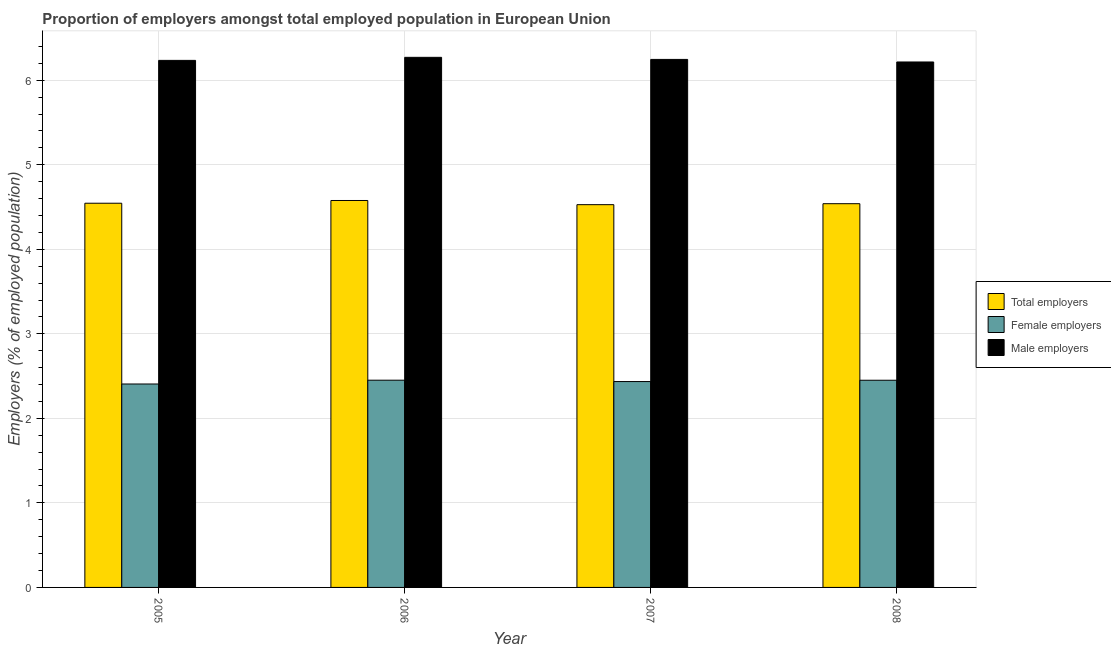How many different coloured bars are there?
Offer a terse response. 3. Are the number of bars on each tick of the X-axis equal?
Provide a succinct answer. Yes. How many bars are there on the 2nd tick from the right?
Your answer should be very brief. 3. What is the label of the 4th group of bars from the left?
Offer a terse response. 2008. In how many cases, is the number of bars for a given year not equal to the number of legend labels?
Offer a terse response. 0. What is the percentage of female employers in 2007?
Your answer should be compact. 2.44. Across all years, what is the maximum percentage of total employers?
Give a very brief answer. 4.58. Across all years, what is the minimum percentage of total employers?
Give a very brief answer. 4.53. In which year was the percentage of female employers maximum?
Offer a terse response. 2006. What is the total percentage of female employers in the graph?
Ensure brevity in your answer.  9.74. What is the difference between the percentage of female employers in 2006 and that in 2008?
Provide a succinct answer. 0. What is the difference between the percentage of total employers in 2006 and the percentage of male employers in 2005?
Your response must be concise. 0.03. What is the average percentage of male employers per year?
Offer a terse response. 6.24. What is the ratio of the percentage of male employers in 2006 to that in 2007?
Your response must be concise. 1. Is the percentage of male employers in 2005 less than that in 2007?
Provide a succinct answer. Yes. Is the difference between the percentage of total employers in 2005 and 2008 greater than the difference between the percentage of female employers in 2005 and 2008?
Give a very brief answer. No. What is the difference between the highest and the second highest percentage of male employers?
Your answer should be very brief. 0.02. What is the difference between the highest and the lowest percentage of total employers?
Provide a succinct answer. 0.05. In how many years, is the percentage of total employers greater than the average percentage of total employers taken over all years?
Give a very brief answer. 1. What does the 3rd bar from the left in 2007 represents?
Your answer should be very brief. Male employers. What does the 1st bar from the right in 2006 represents?
Offer a very short reply. Male employers. Is it the case that in every year, the sum of the percentage of total employers and percentage of female employers is greater than the percentage of male employers?
Provide a short and direct response. Yes. How many bars are there?
Ensure brevity in your answer.  12. What is the difference between two consecutive major ticks on the Y-axis?
Give a very brief answer. 1. Are the values on the major ticks of Y-axis written in scientific E-notation?
Your answer should be compact. No. Where does the legend appear in the graph?
Your response must be concise. Center right. How are the legend labels stacked?
Give a very brief answer. Vertical. What is the title of the graph?
Your answer should be compact. Proportion of employers amongst total employed population in European Union. What is the label or title of the Y-axis?
Your answer should be very brief. Employers (% of employed population). What is the Employers (% of employed population) of Total employers in 2005?
Give a very brief answer. 4.54. What is the Employers (% of employed population) of Female employers in 2005?
Ensure brevity in your answer.  2.41. What is the Employers (% of employed population) in Male employers in 2005?
Offer a terse response. 6.23. What is the Employers (% of employed population) of Total employers in 2006?
Give a very brief answer. 4.58. What is the Employers (% of employed population) of Female employers in 2006?
Your response must be concise. 2.45. What is the Employers (% of employed population) in Male employers in 2006?
Ensure brevity in your answer.  6.27. What is the Employers (% of employed population) in Total employers in 2007?
Your answer should be compact. 4.53. What is the Employers (% of employed population) in Female employers in 2007?
Your answer should be very brief. 2.44. What is the Employers (% of employed population) of Male employers in 2007?
Your response must be concise. 6.25. What is the Employers (% of employed population) of Total employers in 2008?
Your answer should be compact. 4.54. What is the Employers (% of employed population) of Female employers in 2008?
Offer a very short reply. 2.45. What is the Employers (% of employed population) in Male employers in 2008?
Your answer should be very brief. 6.22. Across all years, what is the maximum Employers (% of employed population) in Total employers?
Your answer should be very brief. 4.58. Across all years, what is the maximum Employers (% of employed population) of Female employers?
Keep it short and to the point. 2.45. Across all years, what is the maximum Employers (% of employed population) of Male employers?
Offer a terse response. 6.27. Across all years, what is the minimum Employers (% of employed population) of Total employers?
Offer a terse response. 4.53. Across all years, what is the minimum Employers (% of employed population) of Female employers?
Offer a terse response. 2.41. Across all years, what is the minimum Employers (% of employed population) of Male employers?
Make the answer very short. 6.22. What is the total Employers (% of employed population) in Total employers in the graph?
Provide a short and direct response. 18.19. What is the total Employers (% of employed population) of Female employers in the graph?
Your answer should be very brief. 9.74. What is the total Employers (% of employed population) in Male employers in the graph?
Your response must be concise. 24.97. What is the difference between the Employers (% of employed population) of Total employers in 2005 and that in 2006?
Your response must be concise. -0.03. What is the difference between the Employers (% of employed population) of Female employers in 2005 and that in 2006?
Offer a very short reply. -0.04. What is the difference between the Employers (% of employed population) in Male employers in 2005 and that in 2006?
Your response must be concise. -0.04. What is the difference between the Employers (% of employed population) of Total employers in 2005 and that in 2007?
Your answer should be compact. 0.02. What is the difference between the Employers (% of employed population) in Female employers in 2005 and that in 2007?
Your response must be concise. -0.03. What is the difference between the Employers (% of employed population) of Male employers in 2005 and that in 2007?
Your response must be concise. -0.01. What is the difference between the Employers (% of employed population) in Total employers in 2005 and that in 2008?
Your response must be concise. 0.01. What is the difference between the Employers (% of employed population) of Female employers in 2005 and that in 2008?
Offer a terse response. -0.04. What is the difference between the Employers (% of employed population) in Male employers in 2005 and that in 2008?
Provide a short and direct response. 0.02. What is the difference between the Employers (% of employed population) in Total employers in 2006 and that in 2007?
Ensure brevity in your answer.  0.05. What is the difference between the Employers (% of employed population) in Female employers in 2006 and that in 2007?
Provide a succinct answer. 0.02. What is the difference between the Employers (% of employed population) of Male employers in 2006 and that in 2007?
Your response must be concise. 0.02. What is the difference between the Employers (% of employed population) in Total employers in 2006 and that in 2008?
Offer a terse response. 0.04. What is the difference between the Employers (% of employed population) of Female employers in 2006 and that in 2008?
Offer a terse response. 0. What is the difference between the Employers (% of employed population) in Male employers in 2006 and that in 2008?
Your answer should be very brief. 0.06. What is the difference between the Employers (% of employed population) of Total employers in 2007 and that in 2008?
Offer a very short reply. -0.01. What is the difference between the Employers (% of employed population) in Female employers in 2007 and that in 2008?
Offer a very short reply. -0.02. What is the difference between the Employers (% of employed population) in Male employers in 2007 and that in 2008?
Provide a short and direct response. 0.03. What is the difference between the Employers (% of employed population) of Total employers in 2005 and the Employers (% of employed population) of Female employers in 2006?
Your response must be concise. 2.09. What is the difference between the Employers (% of employed population) of Total employers in 2005 and the Employers (% of employed population) of Male employers in 2006?
Give a very brief answer. -1.73. What is the difference between the Employers (% of employed population) of Female employers in 2005 and the Employers (% of employed population) of Male employers in 2006?
Offer a terse response. -3.86. What is the difference between the Employers (% of employed population) in Total employers in 2005 and the Employers (% of employed population) in Female employers in 2007?
Give a very brief answer. 2.11. What is the difference between the Employers (% of employed population) of Total employers in 2005 and the Employers (% of employed population) of Male employers in 2007?
Ensure brevity in your answer.  -1.7. What is the difference between the Employers (% of employed population) in Female employers in 2005 and the Employers (% of employed population) in Male employers in 2007?
Provide a short and direct response. -3.84. What is the difference between the Employers (% of employed population) of Total employers in 2005 and the Employers (% of employed population) of Female employers in 2008?
Your answer should be compact. 2.09. What is the difference between the Employers (% of employed population) of Total employers in 2005 and the Employers (% of employed population) of Male employers in 2008?
Your answer should be compact. -1.67. What is the difference between the Employers (% of employed population) in Female employers in 2005 and the Employers (% of employed population) in Male employers in 2008?
Make the answer very short. -3.81. What is the difference between the Employers (% of employed population) in Total employers in 2006 and the Employers (% of employed population) in Female employers in 2007?
Your answer should be compact. 2.14. What is the difference between the Employers (% of employed population) in Total employers in 2006 and the Employers (% of employed population) in Male employers in 2007?
Keep it short and to the point. -1.67. What is the difference between the Employers (% of employed population) in Female employers in 2006 and the Employers (% of employed population) in Male employers in 2007?
Keep it short and to the point. -3.79. What is the difference between the Employers (% of employed population) of Total employers in 2006 and the Employers (% of employed population) of Female employers in 2008?
Provide a short and direct response. 2.13. What is the difference between the Employers (% of employed population) in Total employers in 2006 and the Employers (% of employed population) in Male employers in 2008?
Your answer should be compact. -1.64. What is the difference between the Employers (% of employed population) of Female employers in 2006 and the Employers (% of employed population) of Male employers in 2008?
Your response must be concise. -3.76. What is the difference between the Employers (% of employed population) in Total employers in 2007 and the Employers (% of employed population) in Female employers in 2008?
Offer a very short reply. 2.08. What is the difference between the Employers (% of employed population) in Total employers in 2007 and the Employers (% of employed population) in Male employers in 2008?
Offer a terse response. -1.69. What is the difference between the Employers (% of employed population) in Female employers in 2007 and the Employers (% of employed population) in Male employers in 2008?
Your answer should be very brief. -3.78. What is the average Employers (% of employed population) of Total employers per year?
Make the answer very short. 4.55. What is the average Employers (% of employed population) in Female employers per year?
Keep it short and to the point. 2.44. What is the average Employers (% of employed population) of Male employers per year?
Your answer should be very brief. 6.24. In the year 2005, what is the difference between the Employers (% of employed population) in Total employers and Employers (% of employed population) in Female employers?
Ensure brevity in your answer.  2.14. In the year 2005, what is the difference between the Employers (% of employed population) in Total employers and Employers (% of employed population) in Male employers?
Your response must be concise. -1.69. In the year 2005, what is the difference between the Employers (% of employed population) in Female employers and Employers (% of employed population) in Male employers?
Your answer should be compact. -3.83. In the year 2006, what is the difference between the Employers (% of employed population) of Total employers and Employers (% of employed population) of Female employers?
Provide a succinct answer. 2.13. In the year 2006, what is the difference between the Employers (% of employed population) of Total employers and Employers (% of employed population) of Male employers?
Make the answer very short. -1.69. In the year 2006, what is the difference between the Employers (% of employed population) in Female employers and Employers (% of employed population) in Male employers?
Provide a short and direct response. -3.82. In the year 2007, what is the difference between the Employers (% of employed population) in Total employers and Employers (% of employed population) in Female employers?
Make the answer very short. 2.09. In the year 2007, what is the difference between the Employers (% of employed population) of Total employers and Employers (% of employed population) of Male employers?
Make the answer very short. -1.72. In the year 2007, what is the difference between the Employers (% of employed population) of Female employers and Employers (% of employed population) of Male employers?
Offer a terse response. -3.81. In the year 2008, what is the difference between the Employers (% of employed population) of Total employers and Employers (% of employed population) of Female employers?
Keep it short and to the point. 2.09. In the year 2008, what is the difference between the Employers (% of employed population) of Total employers and Employers (% of employed population) of Male employers?
Offer a very short reply. -1.68. In the year 2008, what is the difference between the Employers (% of employed population) of Female employers and Employers (% of employed population) of Male employers?
Your answer should be compact. -3.77. What is the ratio of the Employers (% of employed population) in Total employers in 2005 to that in 2006?
Offer a very short reply. 0.99. What is the ratio of the Employers (% of employed population) of Female employers in 2005 to that in 2006?
Offer a terse response. 0.98. What is the ratio of the Employers (% of employed population) of Male employers in 2005 to that in 2006?
Offer a very short reply. 0.99. What is the ratio of the Employers (% of employed population) of Total employers in 2005 to that in 2007?
Offer a terse response. 1. What is the ratio of the Employers (% of employed population) of Male employers in 2005 to that in 2007?
Ensure brevity in your answer.  1. What is the ratio of the Employers (% of employed population) of Female employers in 2005 to that in 2008?
Provide a short and direct response. 0.98. What is the ratio of the Employers (% of employed population) of Male employers in 2005 to that in 2008?
Keep it short and to the point. 1. What is the ratio of the Employers (% of employed population) in Total employers in 2006 to that in 2007?
Your answer should be very brief. 1.01. What is the ratio of the Employers (% of employed population) in Female employers in 2006 to that in 2007?
Your response must be concise. 1.01. What is the ratio of the Employers (% of employed population) in Male employers in 2006 to that in 2007?
Your response must be concise. 1. What is the ratio of the Employers (% of employed population) of Total employers in 2006 to that in 2008?
Offer a terse response. 1.01. What is the ratio of the Employers (% of employed population) in Female employers in 2006 to that in 2008?
Your answer should be compact. 1. What is the ratio of the Employers (% of employed population) of Male employers in 2006 to that in 2008?
Provide a short and direct response. 1.01. What is the ratio of the Employers (% of employed population) in Female employers in 2007 to that in 2008?
Offer a very short reply. 0.99. What is the difference between the highest and the second highest Employers (% of employed population) of Total employers?
Provide a short and direct response. 0.03. What is the difference between the highest and the second highest Employers (% of employed population) in Female employers?
Your answer should be compact. 0. What is the difference between the highest and the second highest Employers (% of employed population) in Male employers?
Make the answer very short. 0.02. What is the difference between the highest and the lowest Employers (% of employed population) in Total employers?
Keep it short and to the point. 0.05. What is the difference between the highest and the lowest Employers (% of employed population) in Female employers?
Give a very brief answer. 0.04. What is the difference between the highest and the lowest Employers (% of employed population) in Male employers?
Your answer should be compact. 0.06. 